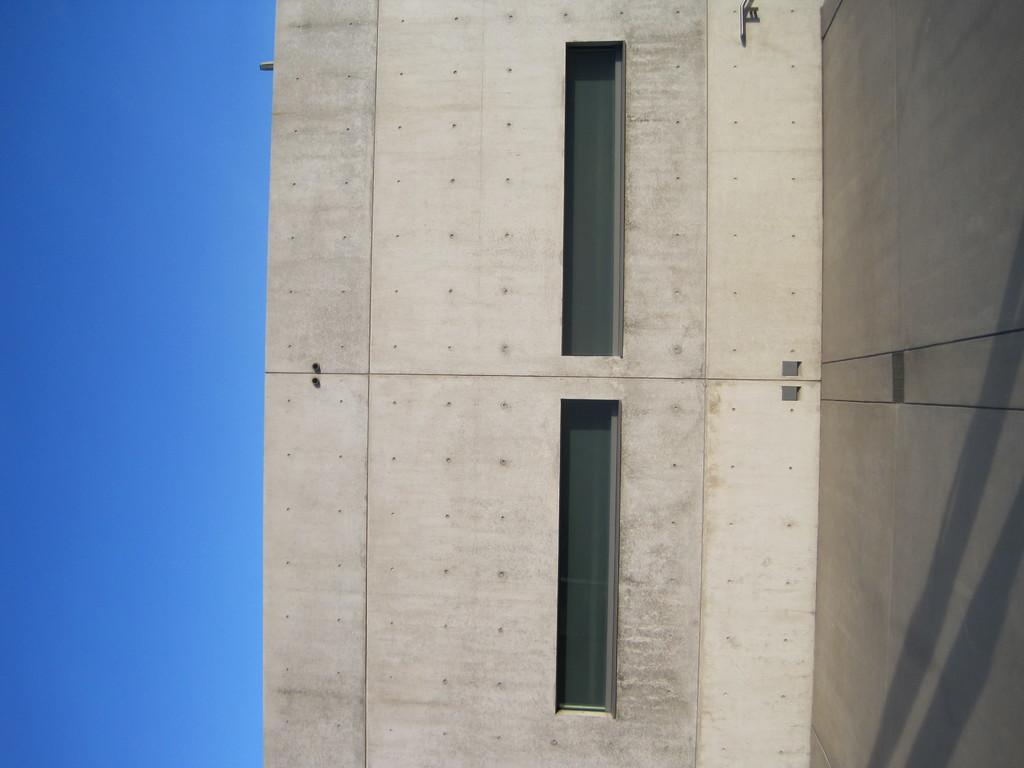What type of structure is visible in the image? There is a wall in the image. Are there any openings in the wall? Yes, there are windows in the image. What can be seen on the left side of the image? The sky is visible on the left side of the image. Can you see the hands of the person smiling in the image? There is no person or smile present in the image; it only features a wall and windows. Is there a tent visible in the image? There is no tent present in the image; it only features a wall and windows. 